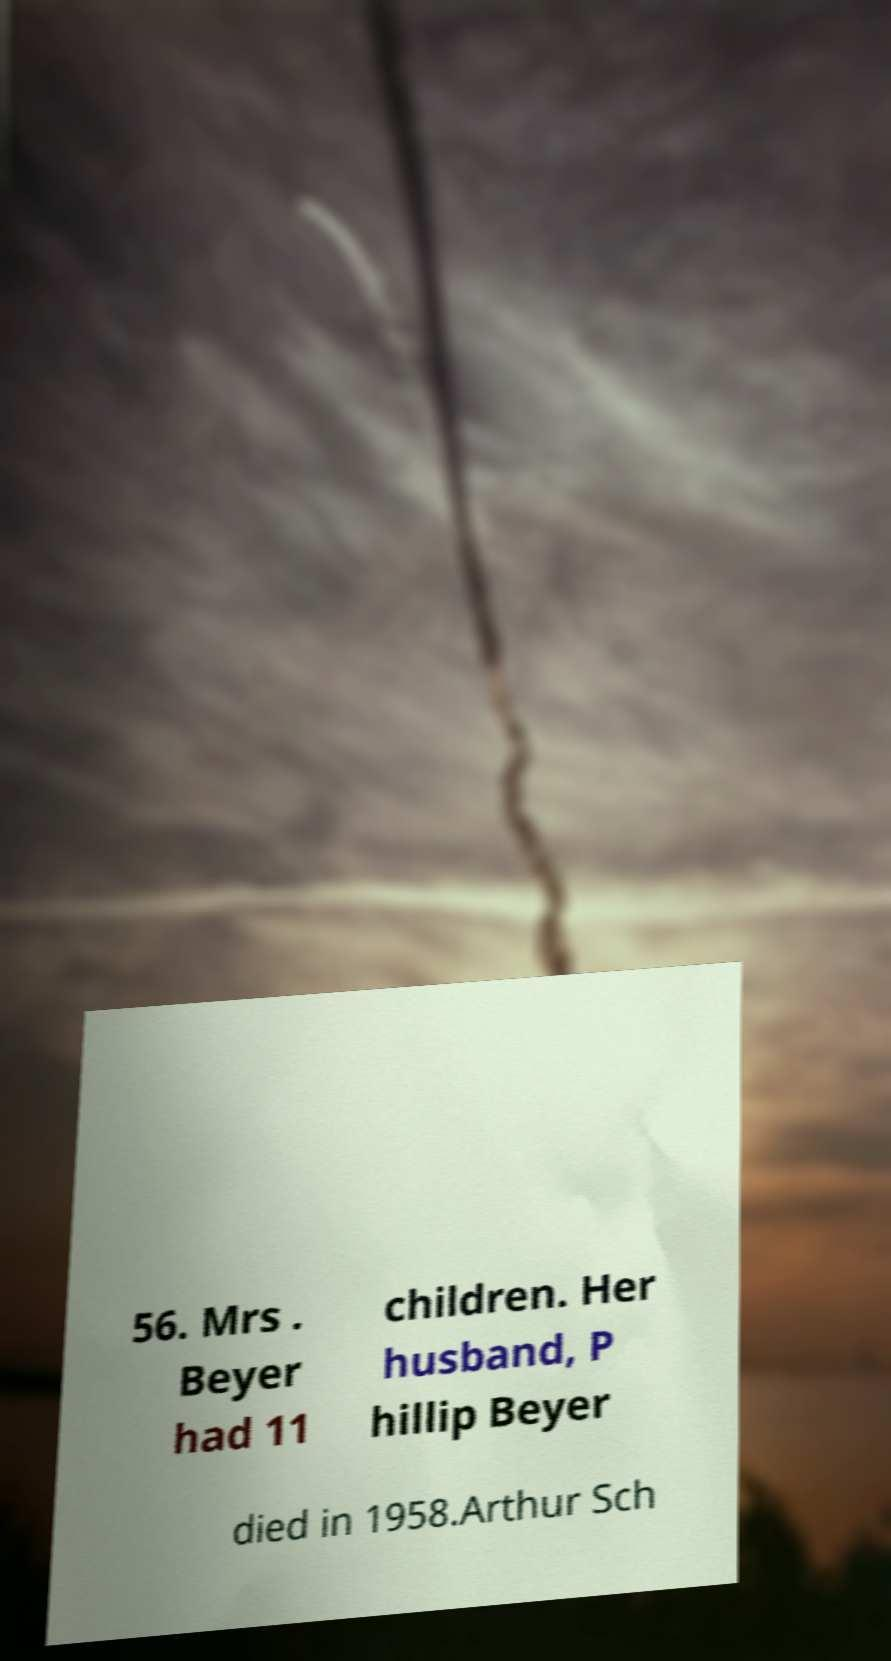What messages or text are displayed in this image? I need them in a readable, typed format. 56. Mrs . Beyer had 11 children. Her husband, P hillip Beyer died in 1958.Arthur Sch 